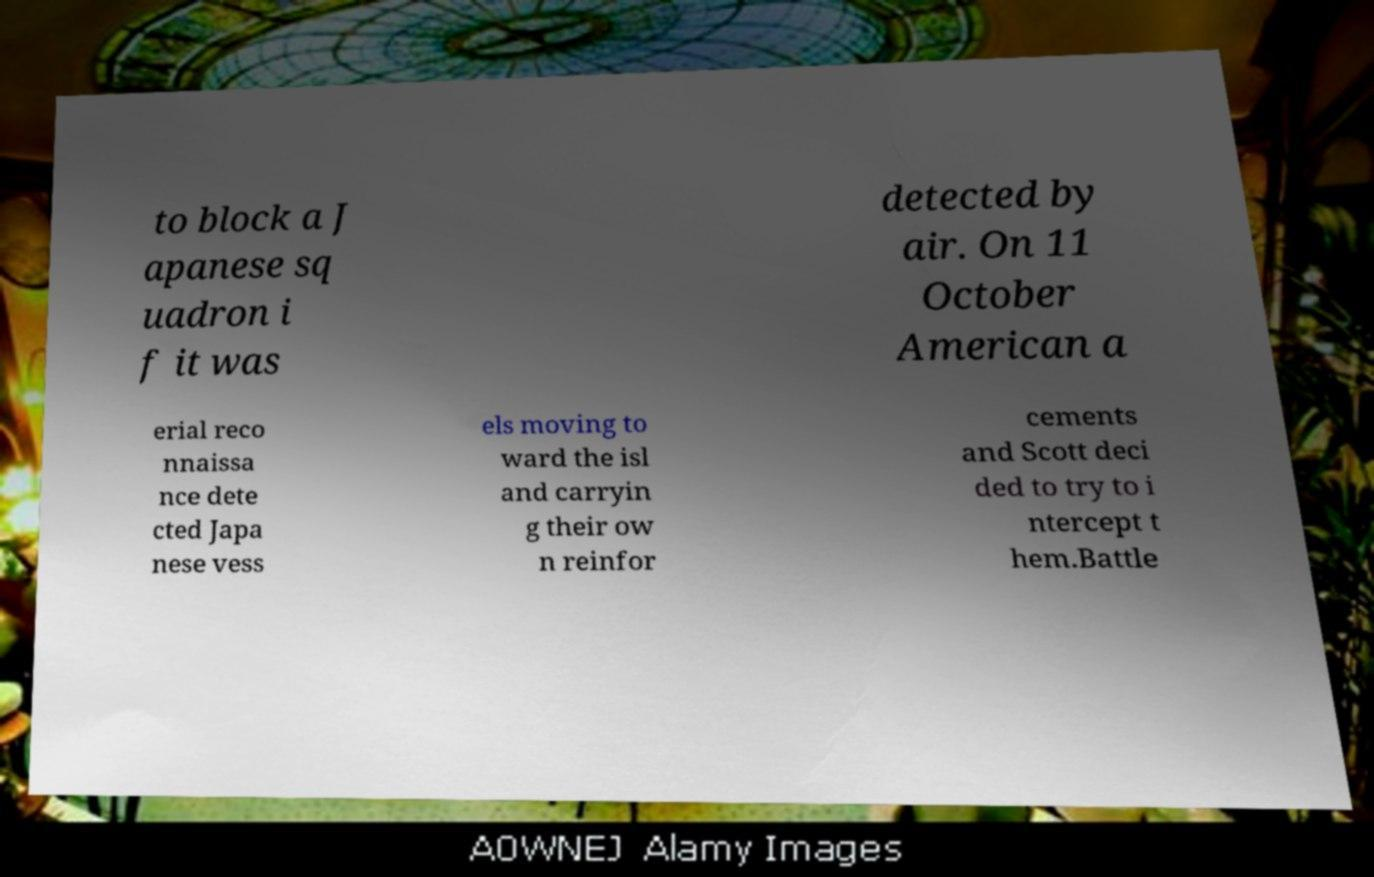Please read and relay the text visible in this image. What does it say? to block a J apanese sq uadron i f it was detected by air. On 11 October American a erial reco nnaissa nce dete cted Japa nese vess els moving to ward the isl and carryin g their ow n reinfor cements and Scott deci ded to try to i ntercept t hem.Battle 